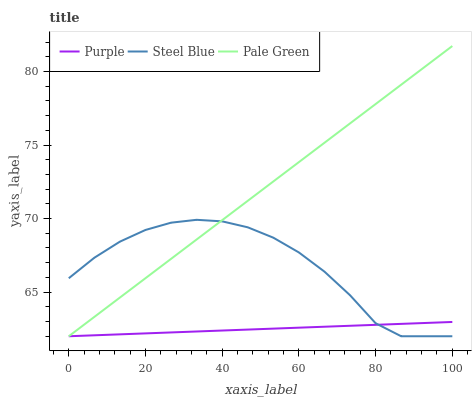Does Purple have the minimum area under the curve?
Answer yes or no. Yes. Does Pale Green have the maximum area under the curve?
Answer yes or no. Yes. Does Steel Blue have the minimum area under the curve?
Answer yes or no. No. Does Steel Blue have the maximum area under the curve?
Answer yes or no. No. Is Purple the smoothest?
Answer yes or no. Yes. Is Steel Blue the roughest?
Answer yes or no. Yes. Is Pale Green the smoothest?
Answer yes or no. No. Is Pale Green the roughest?
Answer yes or no. No. Does Purple have the lowest value?
Answer yes or no. Yes. Does Pale Green have the highest value?
Answer yes or no. Yes. Does Steel Blue have the highest value?
Answer yes or no. No. Does Purple intersect Pale Green?
Answer yes or no. Yes. Is Purple less than Pale Green?
Answer yes or no. No. Is Purple greater than Pale Green?
Answer yes or no. No. 